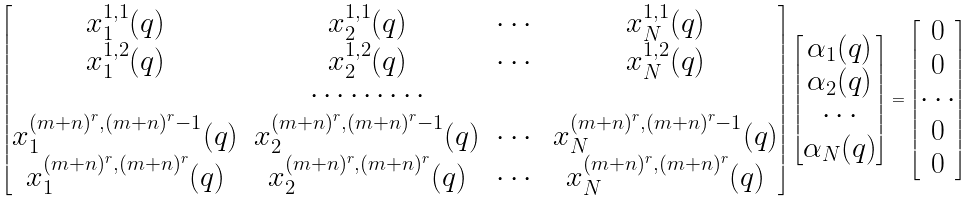Convert formula to latex. <formula><loc_0><loc_0><loc_500><loc_500>\begin{bmatrix} x _ { 1 } ^ { 1 , 1 } ( q ) & x _ { 2 } ^ { 1 , 1 } ( q ) & \cdots & x _ { N } ^ { 1 , 1 } ( q ) \\ x _ { 1 } ^ { 1 , 2 } ( q ) & x _ { 2 } ^ { 1 , 2 } ( q ) & \cdots & x _ { N } ^ { 1 , 2 } ( q ) \\ & \cdots \cdots \cdots \\ x _ { 1 } ^ { ( m + n ) ^ { r } , ( m + n ) ^ { r } - 1 } ( q ) & x _ { 2 } ^ { ( m + n ) ^ { r } , ( m + n ) ^ { r } - 1 } ( q ) & \cdots & x _ { N } ^ { ( m + n ) ^ { r } , ( m + n ) ^ { r } - 1 } ( q ) \\ x _ { 1 } ^ { ( m + n ) ^ { r } , ( m + n ) ^ { r } } ( q ) & x _ { 2 } ^ { ( m + n ) ^ { r } , ( m + n ) ^ { r } } ( q ) & \cdots & x _ { N } ^ { ( m + n ) ^ { r } , ( m + n ) ^ { r } } ( q ) \end{bmatrix} \begin{bmatrix} \alpha _ { 1 } ( q ) \\ \alpha _ { 2 } ( q ) \\ \cdots \\ \alpha _ { N } ( q ) \end{bmatrix} = \begin{bmatrix} 0 \\ 0 \\ \cdots \\ 0 \\ 0 \end{bmatrix}</formula> 